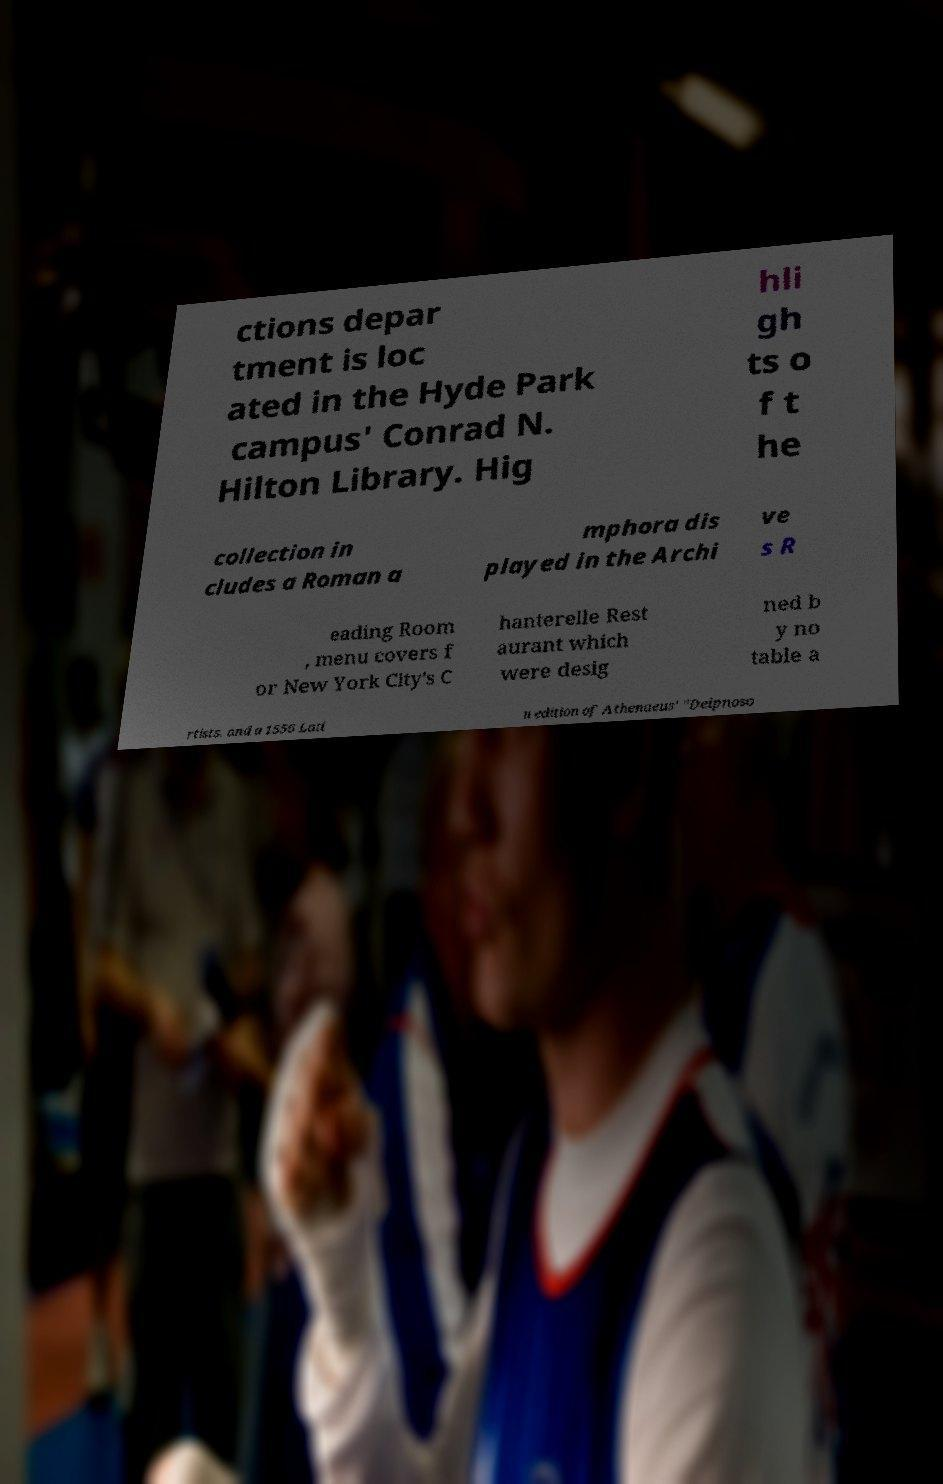Please identify and transcribe the text found in this image. ctions depar tment is loc ated in the Hyde Park campus' Conrad N. Hilton Library. Hig hli gh ts o f t he collection in cludes a Roman a mphora dis played in the Archi ve s R eading Room , menu covers f or New York City's C hanterelle Rest aurant which were desig ned b y no table a rtists, and a 1556 Lati n edition of Athenaeus' "Deipnoso 